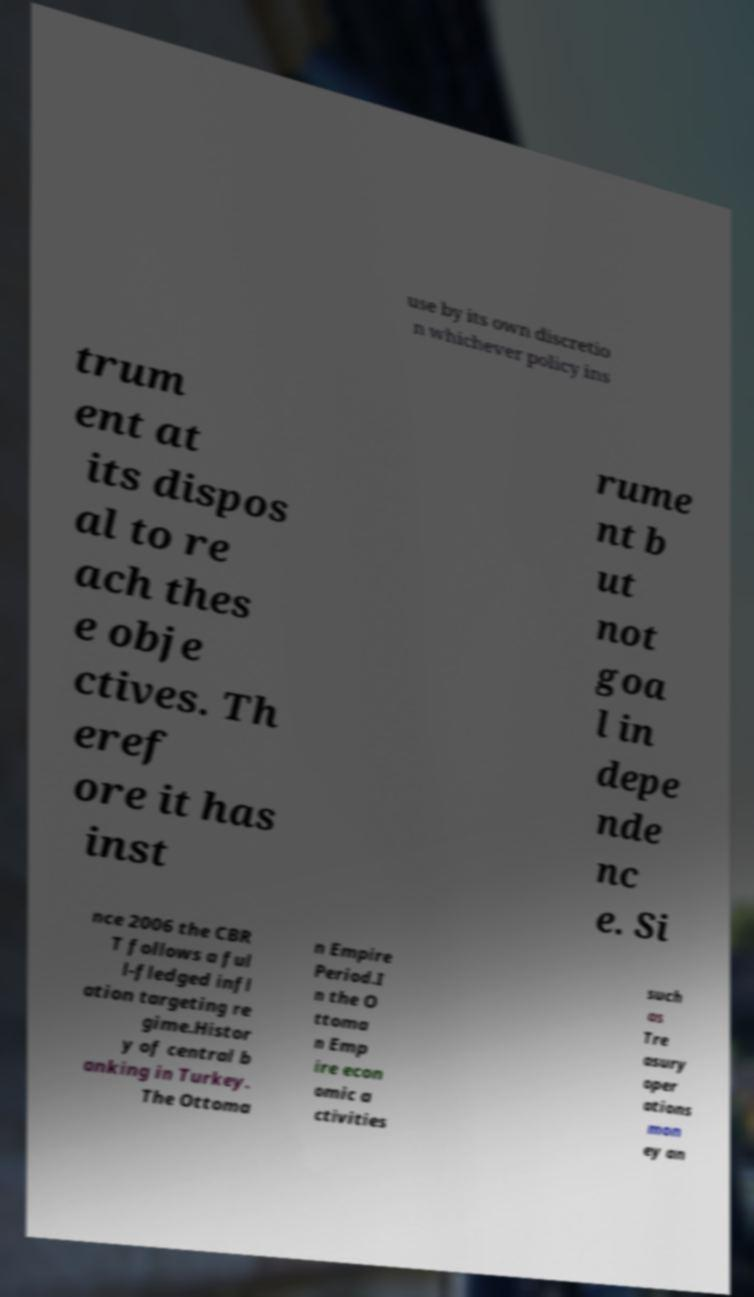Can you read and provide the text displayed in the image?This photo seems to have some interesting text. Can you extract and type it out for me? use by its own discretio n whichever policy ins trum ent at its dispos al to re ach thes e obje ctives. Th eref ore it has inst rume nt b ut not goa l in depe nde nc e. Si nce 2006 the CBR T follows a ful l-fledged infl ation targeting re gime.Histor y of central b anking in Turkey. The Ottoma n Empire Period.I n the O ttoma n Emp ire econ omic a ctivities such as Tre asury oper ations mon ey an 